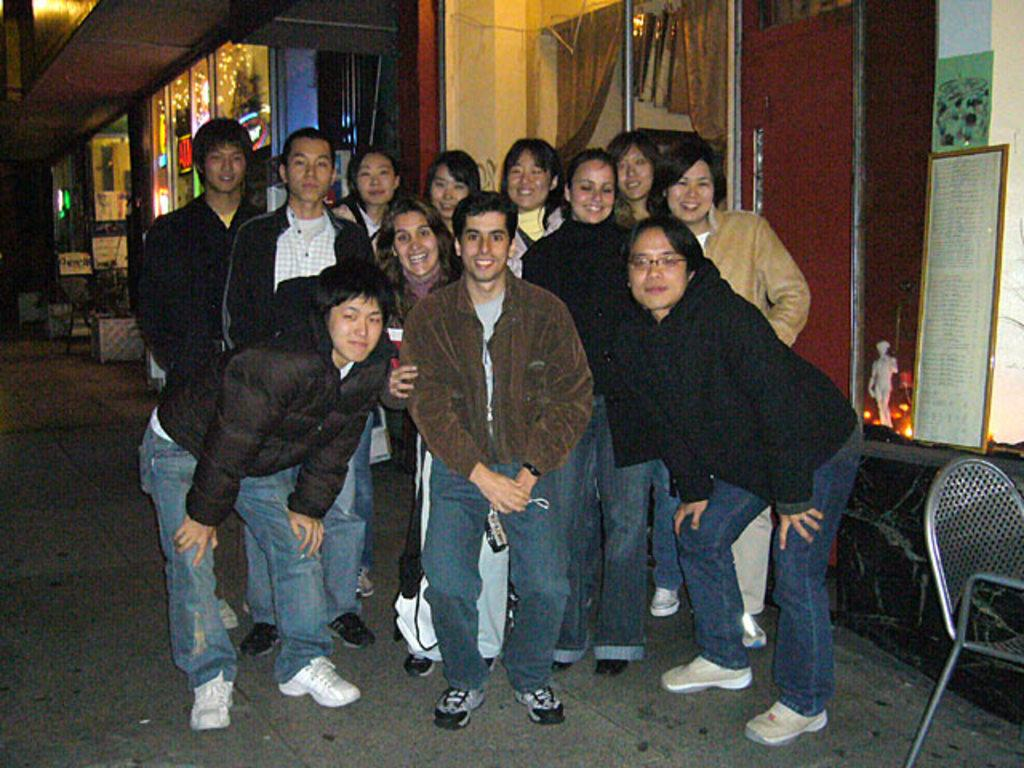What is happening with the group of people in the image? The people in the image are standing and smiling. Can you describe the clothing of one of the people in the group? There is a person wearing a jacket in the image. What is on the ground near the group of people? There is a chair on the ground. What can be seen providing illumination in the image? There is a light in the image. How many horses are present in the image? There are no horses present in the image. What type of drug is being used by the person wearing the jacket? There is no indication of any drug use in the image. 